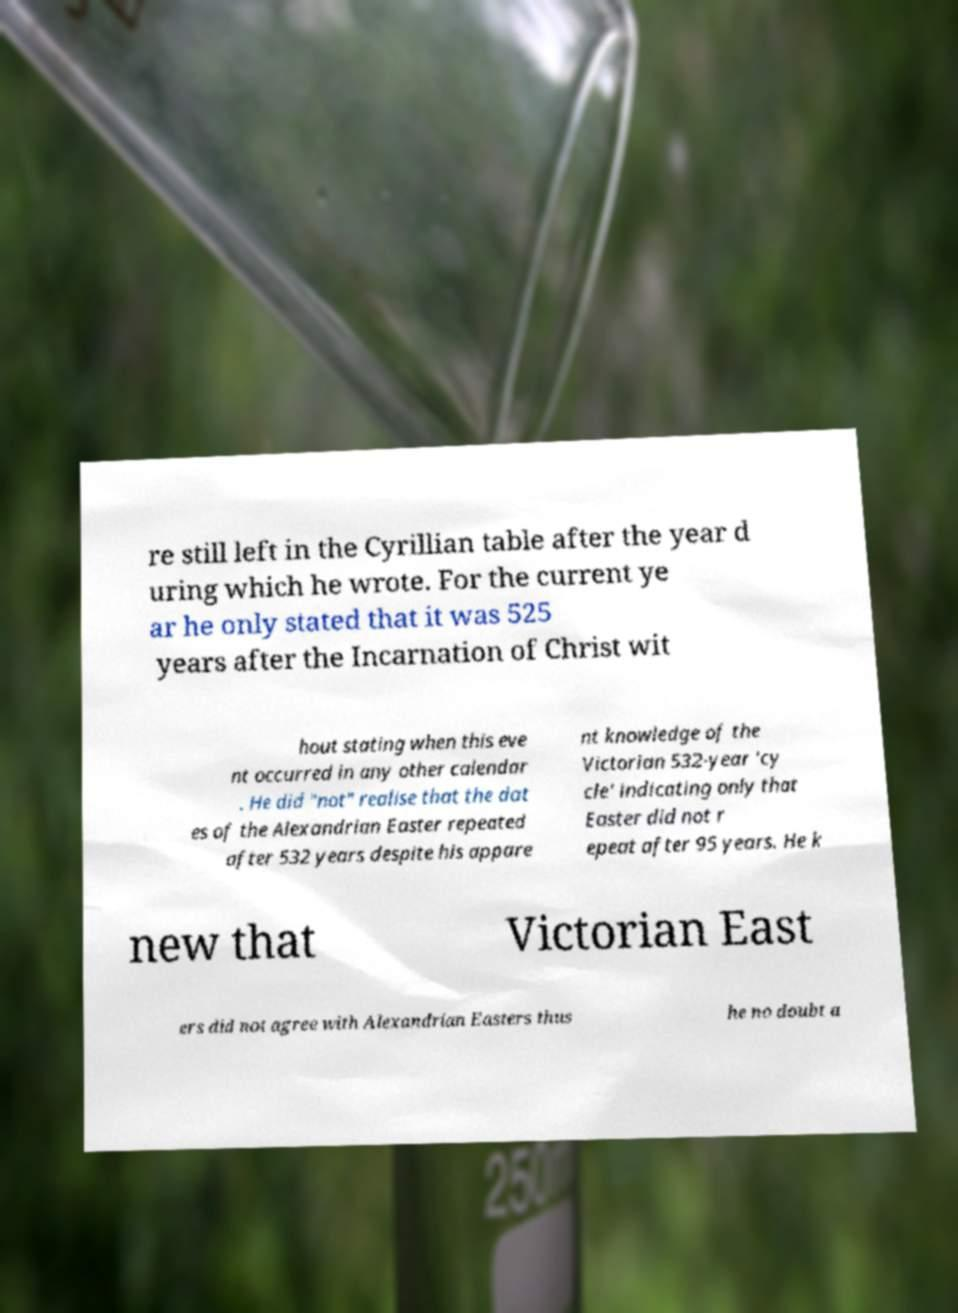Could you extract and type out the text from this image? re still left in the Cyrillian table after the year d uring which he wrote. For the current ye ar he only stated that it was 525 years after the Incarnation of Christ wit hout stating when this eve nt occurred in any other calendar . He did "not" realise that the dat es of the Alexandrian Easter repeated after 532 years despite his appare nt knowledge of the Victorian 532-year 'cy cle' indicating only that Easter did not r epeat after 95 years. He k new that Victorian East ers did not agree with Alexandrian Easters thus he no doubt a 